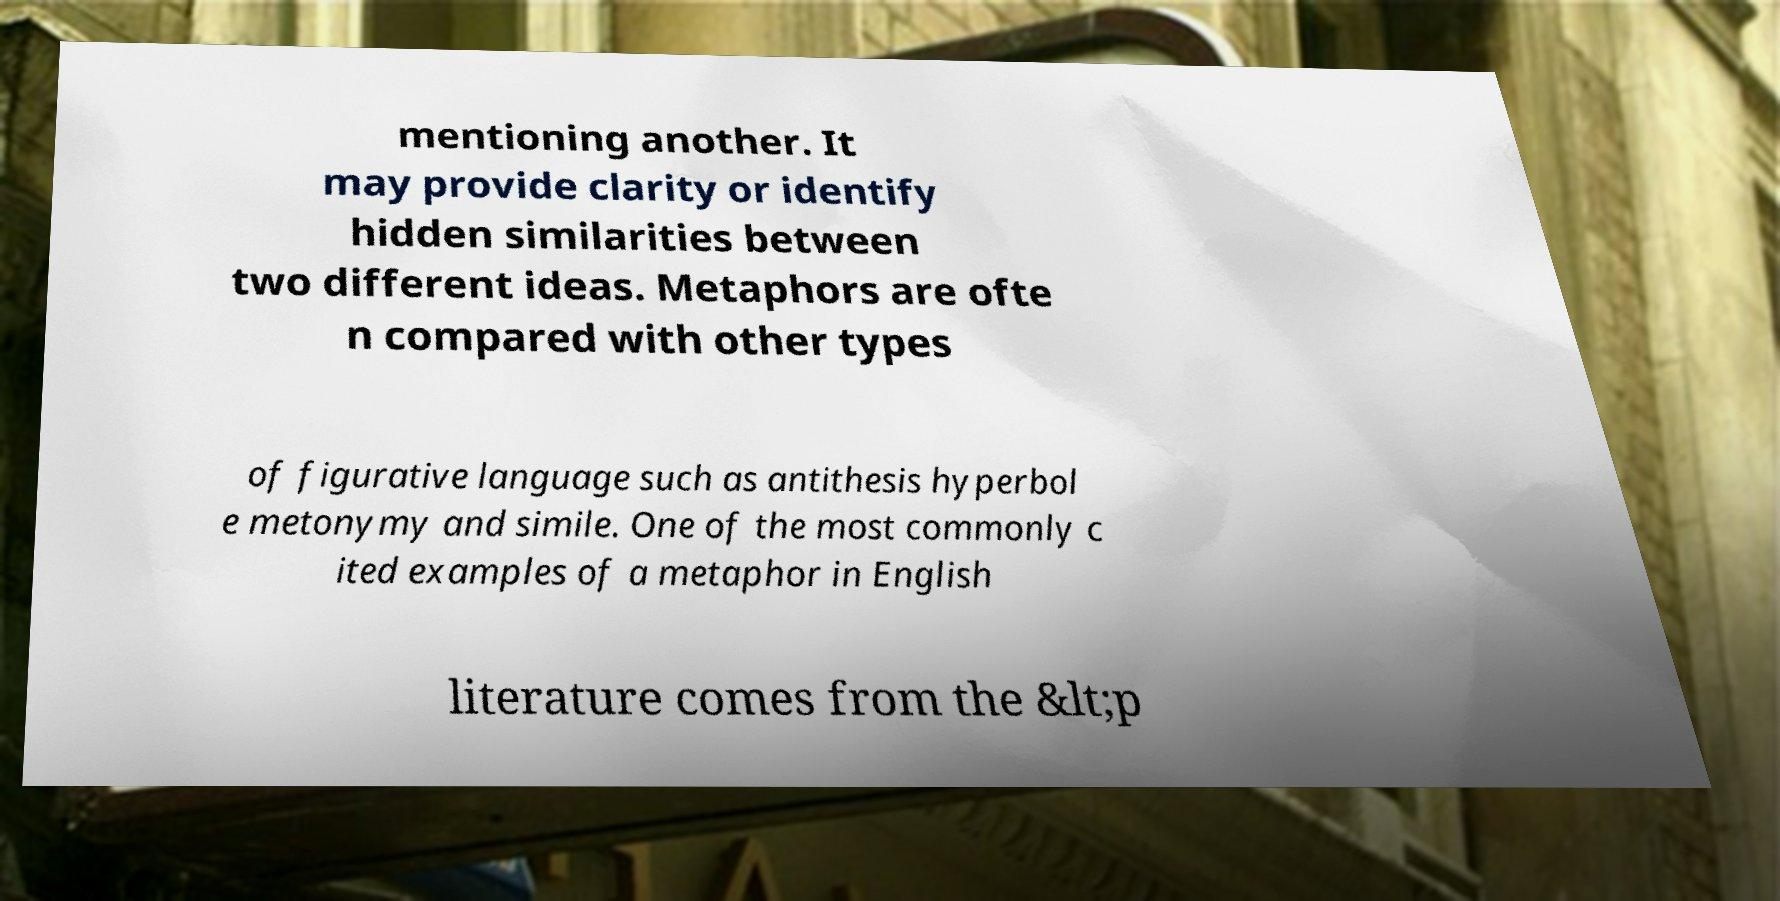Please identify and transcribe the text found in this image. mentioning another. It may provide clarity or identify hidden similarities between two different ideas. Metaphors are ofte n compared with other types of figurative language such as antithesis hyperbol e metonymy and simile. One of the most commonly c ited examples of a metaphor in English literature comes from the &lt;p 